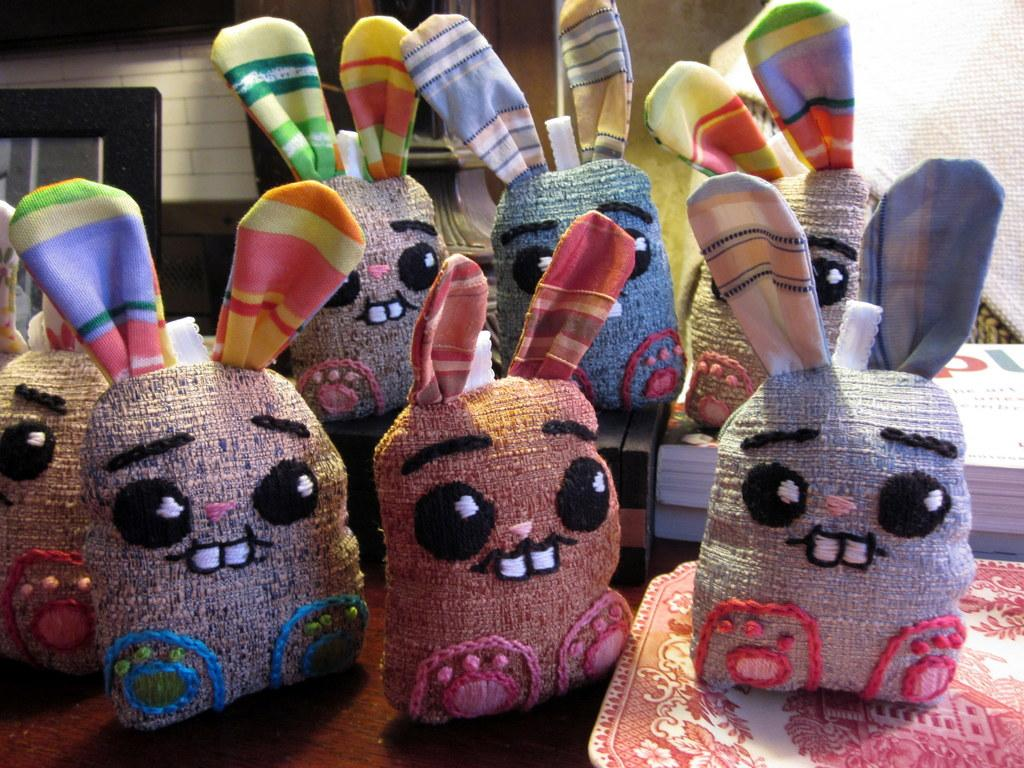What type of flooring is visible in the image? There are white color tiles in the image. What architectural feature can be seen in the image? There is a door in the image. What objects are present in the image? There are bags and tables in the image. Where is the faucet located in the image? There is no faucet present in the image. What type of achievement is being celebrated in the image? The image does not depict any achievements or celebrations. 